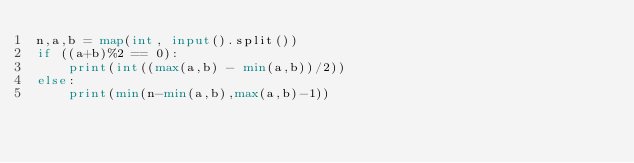<code> <loc_0><loc_0><loc_500><loc_500><_Python_>n,a,b = map(int, input().split())
if ((a+b)%2 == 0):
    print(int((max(a,b) - min(a,b))/2))
else:
    print(min(n-min(a,b),max(a,b)-1))</code> 